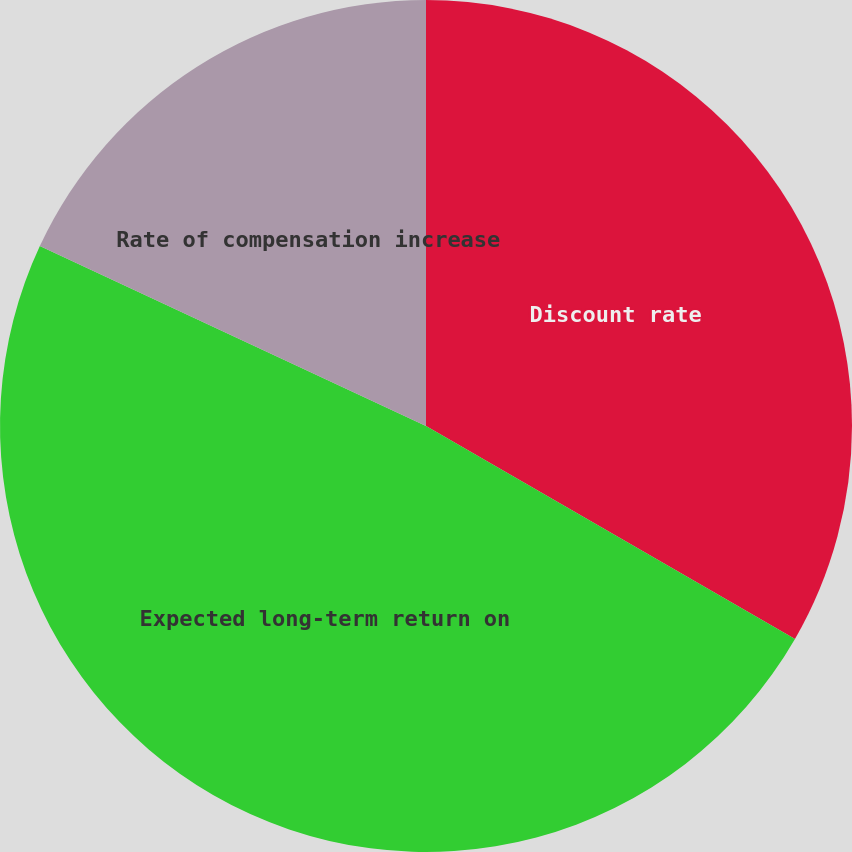<chart> <loc_0><loc_0><loc_500><loc_500><pie_chart><fcel>Discount rate<fcel>Expected long-term return on<fcel>Rate of compensation increase<nl><fcel>33.33%<fcel>48.61%<fcel>18.06%<nl></chart> 